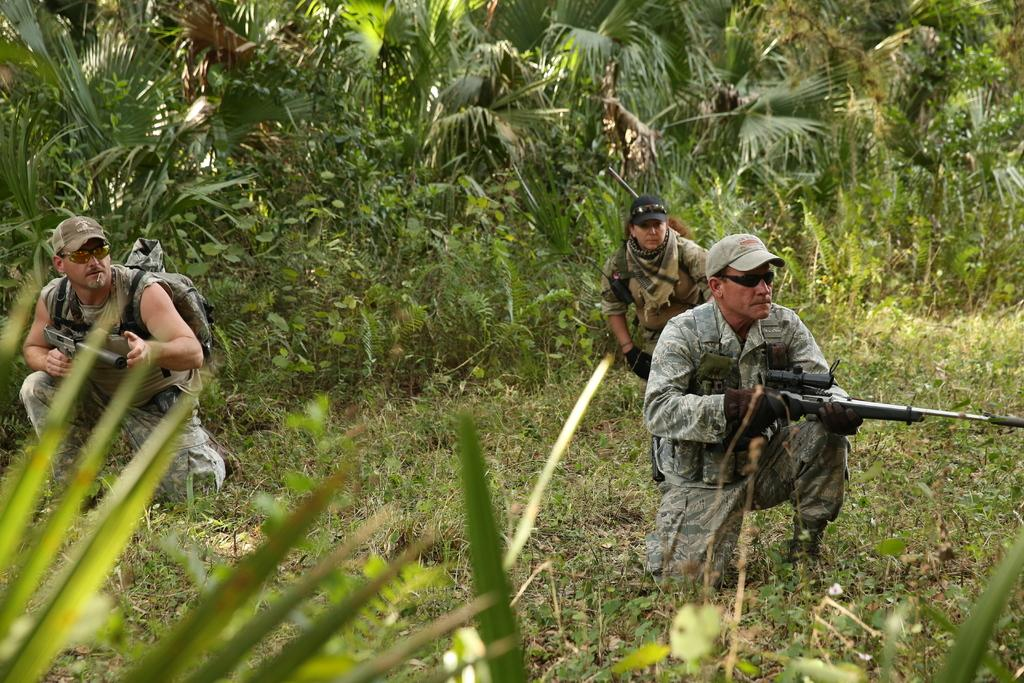Who or what is present in the image? There are people in the image. What are the people holding in their hands? The people are holding rifles in their hands. What type of natural environment can be seen in the image? There are trees, plants, and grass in the image. What type of mouth can be seen on the plants in the image? There are no mouths present on the plants in the image, as plants do not have mouths. 